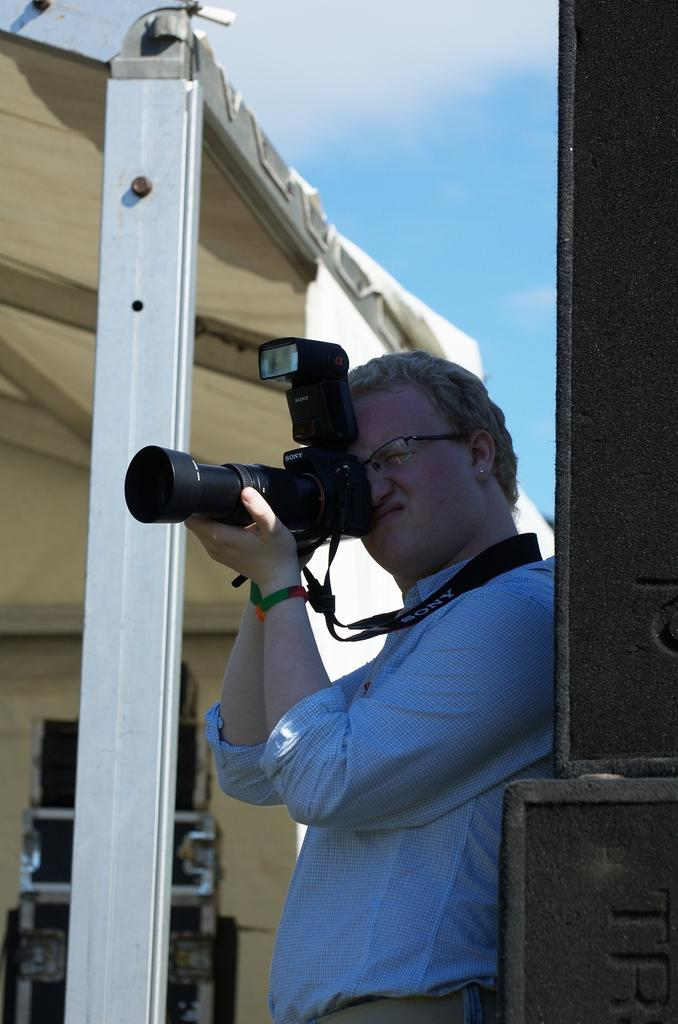Who or what is the main subject in the image? There is a person in the image. What object is also visible in the image? There is a camera in the image. What type of structure can be seen in the background of the image? There is a shed in the background of the image. What part of the natural environment is visible in the image? The sky is visible in the image. How many servants are present in the image? There is no mention of servants in the image; it only features a person, a camera, a shed, and the sky. 